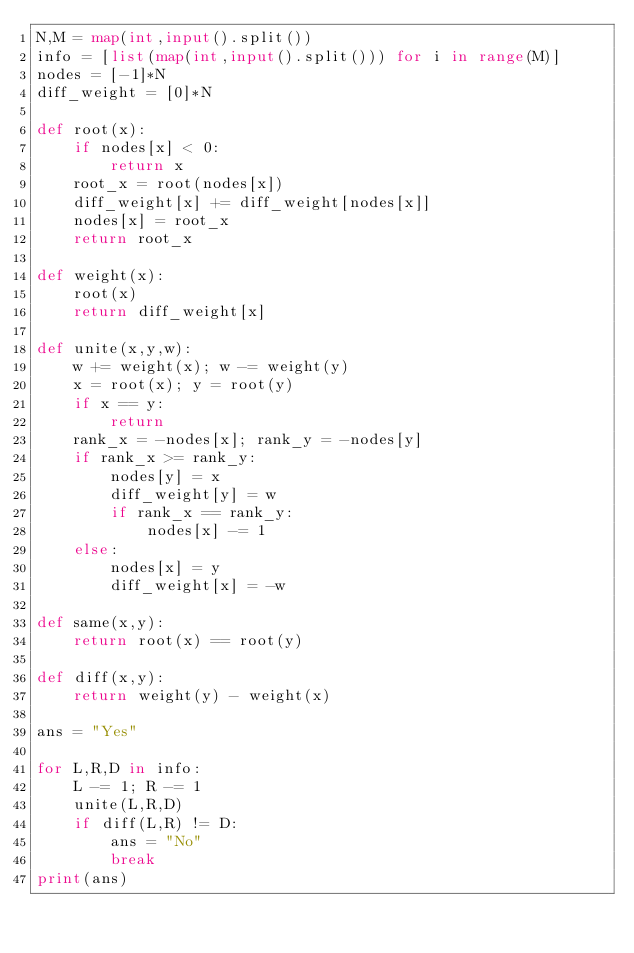<code> <loc_0><loc_0><loc_500><loc_500><_Python_>N,M = map(int,input().split())
info = [list(map(int,input().split())) for i in range(M)]
nodes = [-1]*N
diff_weight = [0]*N

def root(x):
    if nodes[x] < 0:
        return x
    root_x = root(nodes[x])
    diff_weight[x] += diff_weight[nodes[x]]
    nodes[x] = root_x
    return root_x

def weight(x):
    root(x)
    return diff_weight[x]

def unite(x,y,w):
    w += weight(x); w -= weight(y)
    x = root(x); y = root(y)
    if x == y:
        return
    rank_x = -nodes[x]; rank_y = -nodes[y]
    if rank_x >= rank_y:
        nodes[y] = x
        diff_weight[y] = w
        if rank_x == rank_y:
            nodes[x] -= 1
    else:
        nodes[x] = y
        diff_weight[x] = -w

def same(x,y):
    return root(x) == root(y)

def diff(x,y):
    return weight(y) - weight(x)

ans = "Yes"

for L,R,D in info:
    L -= 1; R -= 1
    unite(L,R,D)
    if diff(L,R) != D:
        ans = "No"
        break
print(ans)</code> 